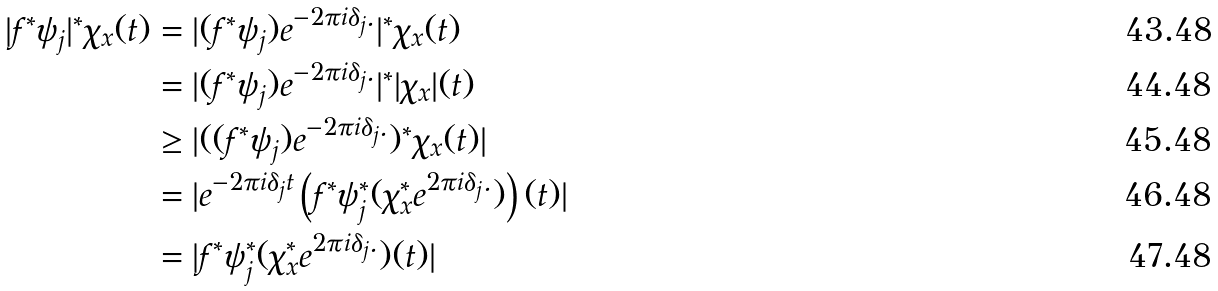<formula> <loc_0><loc_0><loc_500><loc_500>| f ^ { * } \psi _ { j } | ^ { * } \chi _ { x } ( t ) & = | ( f ^ { * } \psi _ { j } ) e ^ { - 2 \pi i \delta _ { j } . } | ^ { * } \chi _ { x } ( t ) \\ & = | ( f ^ { * } \psi _ { j } ) e ^ { - 2 \pi i \delta _ { j } . } | ^ { * } | \chi _ { x } | ( t ) \\ & \geq | ( ( f ^ { * } \psi _ { j } ) e ^ { - 2 \pi i \delta _ { j } . } ) ^ { * } \chi _ { x } ( t ) | \\ & = | e ^ { - 2 \pi i \delta _ { j } t } \left ( f ^ { * } \psi _ { j } ^ { * } ( \chi _ { x } ^ { * } e ^ { 2 \pi i \delta _ { j } . } ) \right ) ( t ) | \\ & = | f ^ { * } \psi _ { j } ^ { * } ( \chi _ { x } ^ { * } e ^ { 2 \pi i \delta _ { j } . } ) ( t ) |</formula> 